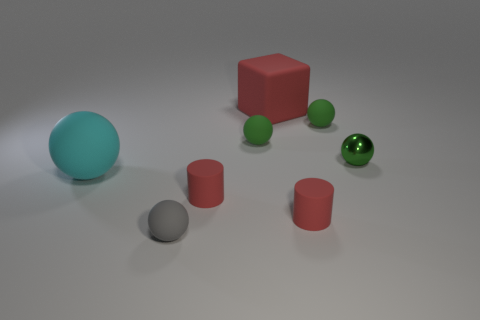Subtract all green cubes. How many green balls are left? 3 Subtract all cyan balls. How many balls are left? 4 Subtract 1 balls. How many balls are left? 4 Subtract all green metal balls. How many balls are left? 4 Subtract all gray balls. Subtract all gray cubes. How many balls are left? 4 Add 2 large cyan balls. How many objects exist? 10 Subtract all cylinders. How many objects are left? 6 Subtract all cyan balls. Subtract all red things. How many objects are left? 4 Add 6 tiny rubber balls. How many tiny rubber balls are left? 9 Add 1 big red rubber things. How many big red rubber things exist? 2 